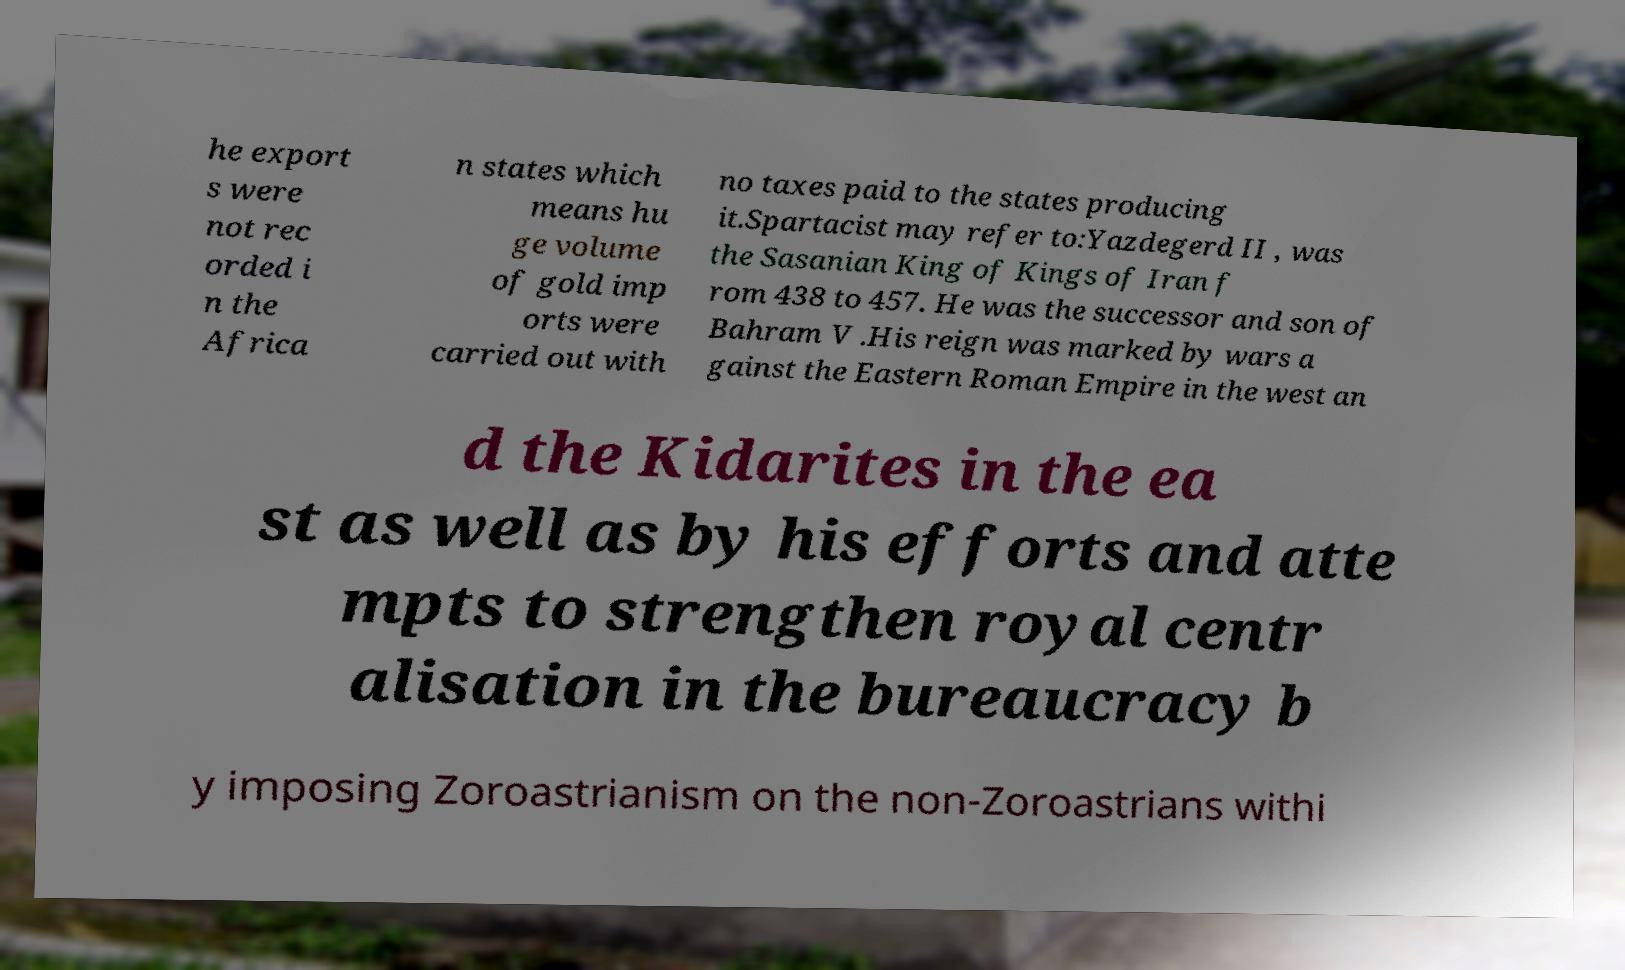I need the written content from this picture converted into text. Can you do that? he export s were not rec orded i n the Africa n states which means hu ge volume of gold imp orts were carried out with no taxes paid to the states producing it.Spartacist may refer to:Yazdegerd II , was the Sasanian King of Kings of Iran f rom 438 to 457. He was the successor and son of Bahram V .His reign was marked by wars a gainst the Eastern Roman Empire in the west an d the Kidarites in the ea st as well as by his efforts and atte mpts to strengthen royal centr alisation in the bureaucracy b y imposing Zoroastrianism on the non-Zoroastrians withi 